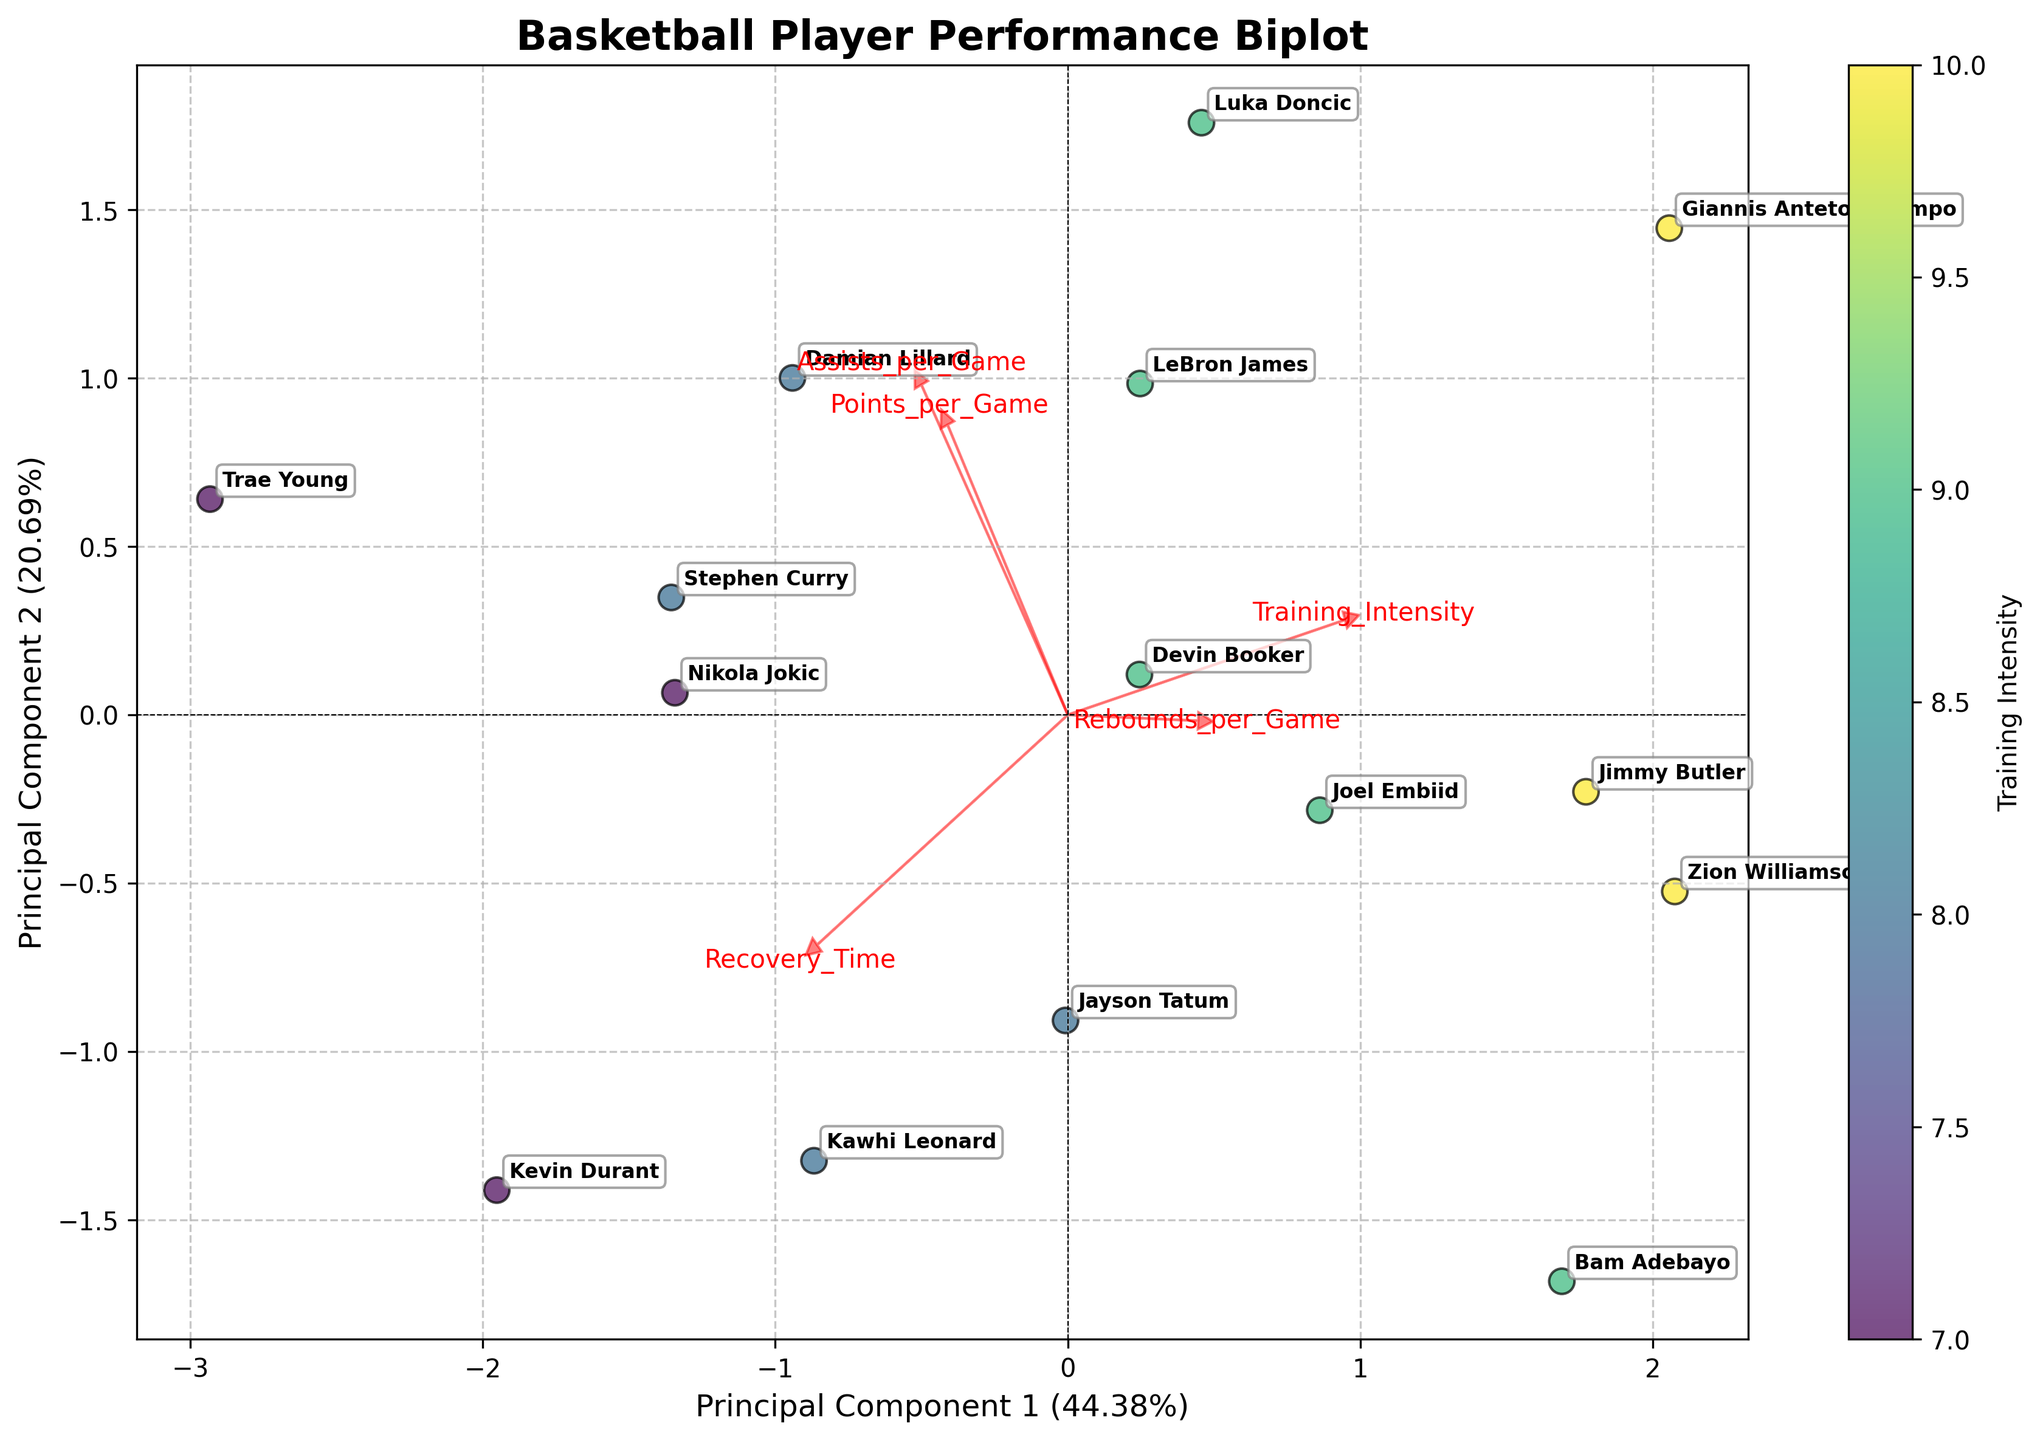How many players are plotted in the biplot? Count the number of unique labels or points on the plot
Answer: 15 What does the color of the points represent? Examine the color key and its label
Answer: Training Intensity Which principal component explains more variance in the data? Look at the x and y labels for the percentage of variance explained
Answer: Principal Component 1 What is the relationship between Training Intensity and Points per Game? Follow the direction of the feature vectors for Training Intensity and Points per Game
Answer: Positive correlation Who has higher recovery time, Stephen Curry or Joel Embiid? Compare the coordinates of Stephen Curry and Joel Embiid along the Recovery Time feature vector
Answer: Stephen Curry Which feature is most positively correlated with Assists per Game based on the biplot vectors? Look at the direction and length of the Assists per Game vector and identify the closest feature
Answer: Training Intensity Is there any player who has a Training Intensity of 10 and also has high points in PC1 and PC2? Look at the points labeled with the Players and the color corresponding to Training Intensity of 10, then check their coordinates
Answer: Giannis Antetokounmpo and Jimmy Butler Considering only the players with a Training Intensity greater than 8, who has the highest Points per Game? Identify players with Training Intensity > 8 by their color, then find the one with the farthest coordinate in the direction of Points per Game
Answer: Giannis Antetokounmpo How does Recovery Time relate to Rebounds per Game? Follow the directions of the feature vectors for Recovery Time and Rebounds per Game
Answer: Negative correlation Among the players with the lowest Training Intensity, who has the highest Assists per Game? Identify points with the lightest color (represent lowest Training Intensity) and check their coordinates related to Assists per Game
Answer: Trae Young 